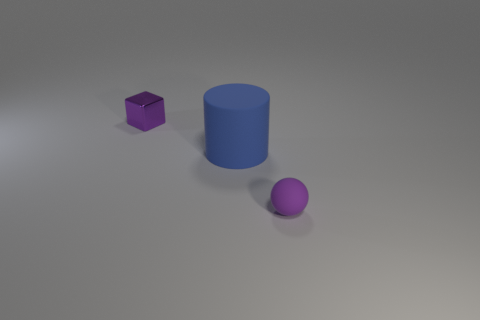There is a object that is on the right side of the small metallic object and behind the tiny matte ball; what material is it? The object on the right of the small metallic cube and behind the matte ball appears to be made of a plastic material with a smooth, matte finish and a consistent color throughout, indicative of typical plastic characteristics. 